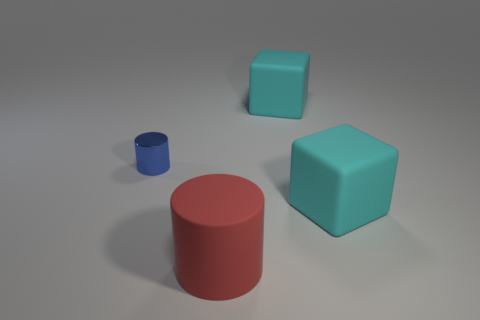Add 2 tiny blue cylinders. How many objects exist? 6 Subtract all blue cylinders. How many cylinders are left? 1 Subtract all blue cylinders. How many purple cubes are left? 0 Subtract all green cylinders. Subtract all brown balls. How many cylinders are left? 2 Subtract all blue rubber cubes. Subtract all large red things. How many objects are left? 3 Add 3 cyan things. How many cyan things are left? 5 Add 2 large rubber cylinders. How many large rubber cylinders exist? 3 Subtract 0 purple balls. How many objects are left? 4 